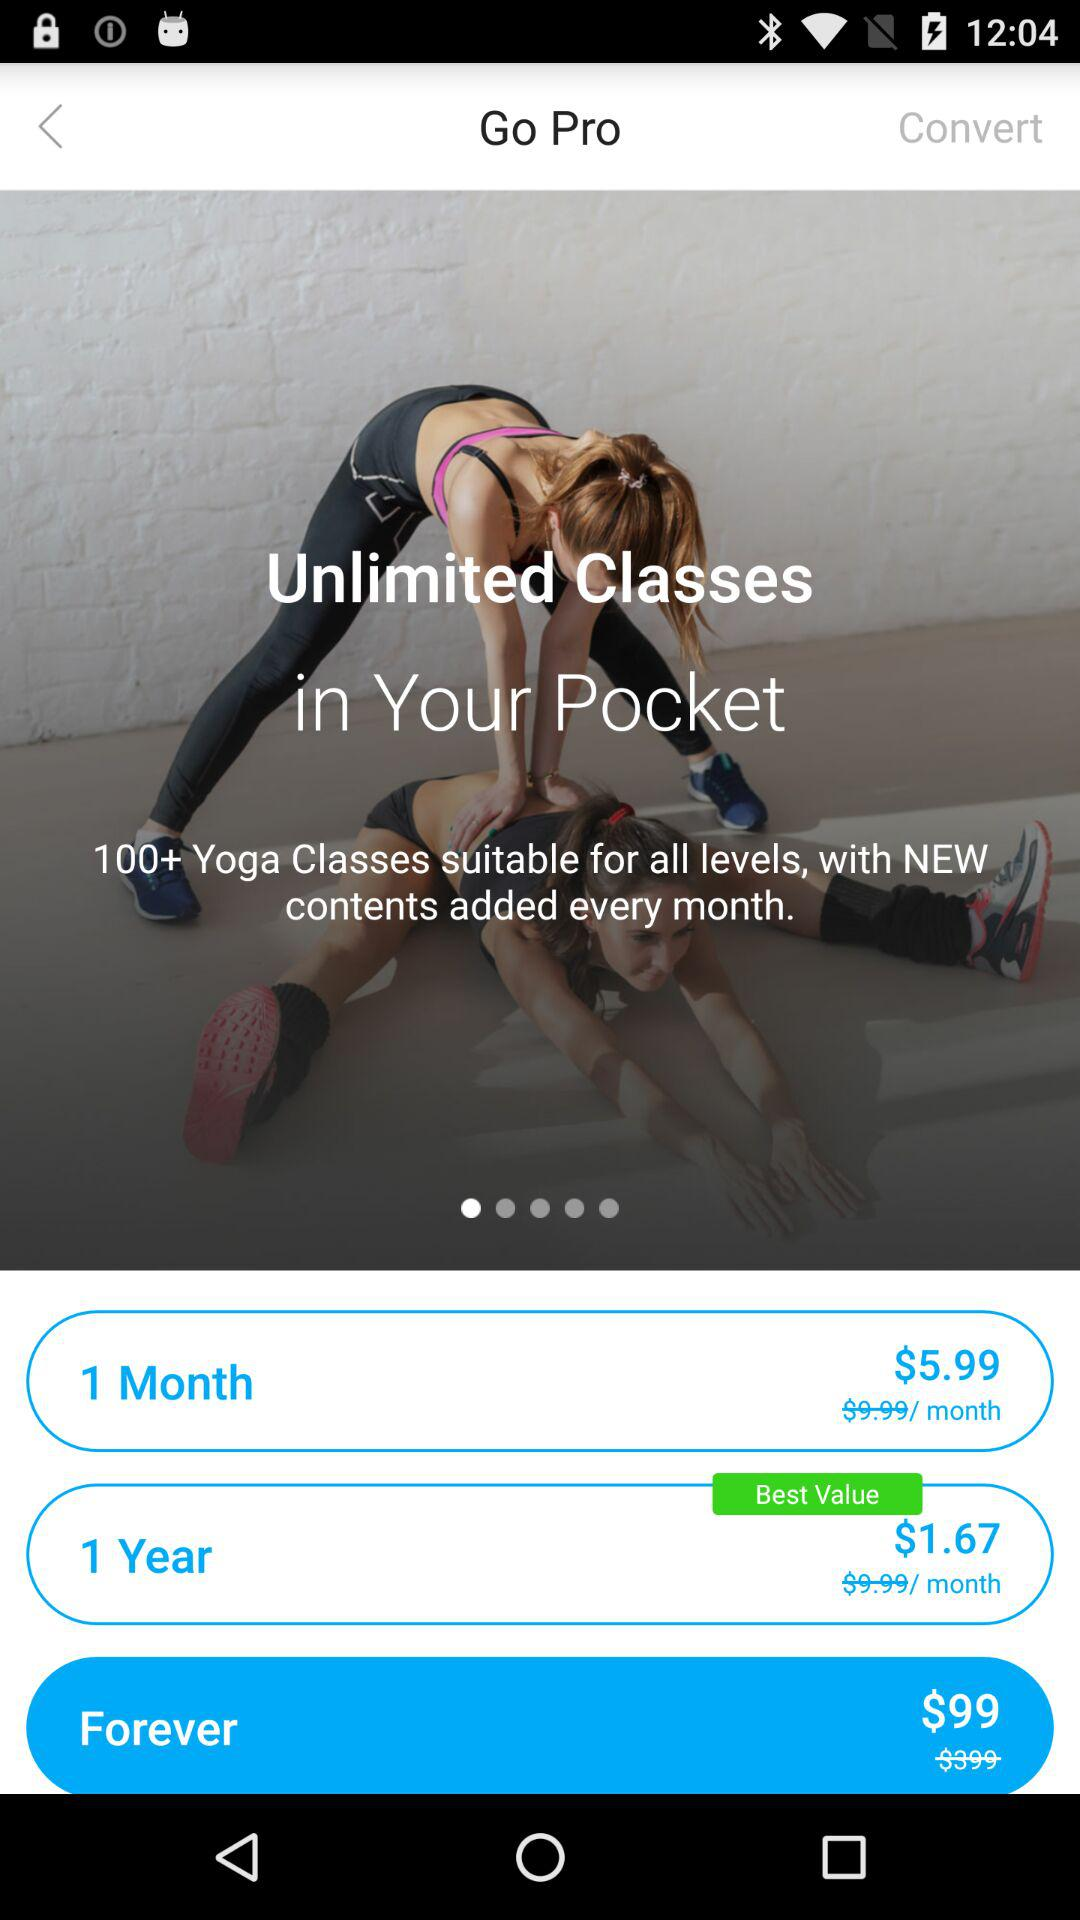How much is the price of one month? The price of one month is $5.99. 